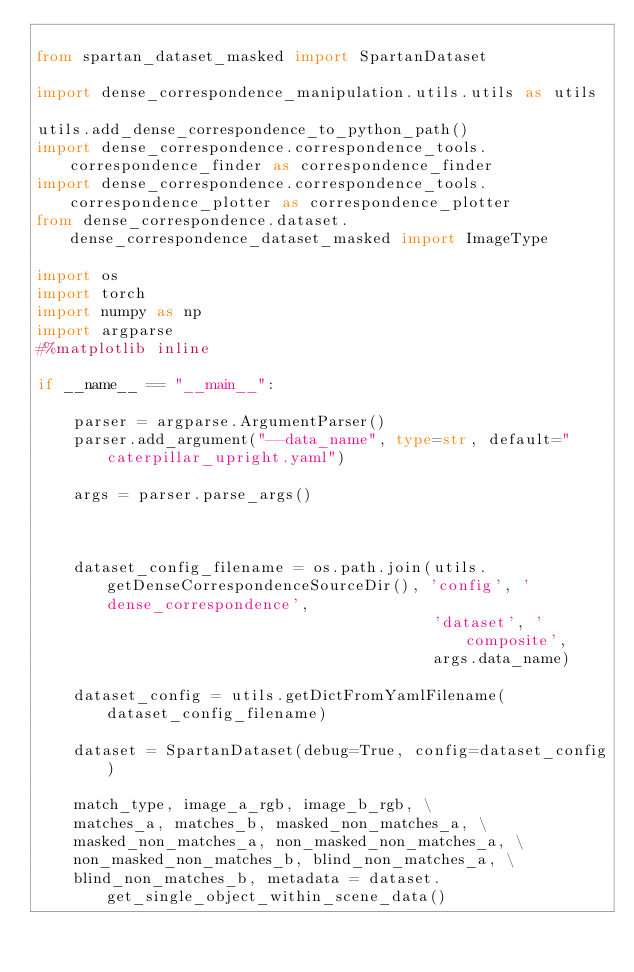<code> <loc_0><loc_0><loc_500><loc_500><_Python_>
from spartan_dataset_masked import SpartanDataset

import dense_correspondence_manipulation.utils.utils as utils

utils.add_dense_correspondence_to_python_path()
import dense_correspondence.correspondence_tools.correspondence_finder as correspondence_finder
import dense_correspondence.correspondence_tools.correspondence_plotter as correspondence_plotter
from dense_correspondence.dataset.dense_correspondence_dataset_masked import ImageType

import os
import torch
import numpy as np
import argparse
#%matplotlib inline

if __name__ == "__main__":

    parser = argparse.ArgumentParser()
    parser.add_argument("--data_name", type=str, default="caterpillar_upright.yaml")

    args = parser.parse_args()



    dataset_config_filename = os.path.join(utils.getDenseCorrespondenceSourceDir(), 'config', 'dense_correspondence',
                                           'dataset', 'composite',
                                           args.data_name)

    dataset_config = utils.getDictFromYamlFilename(dataset_config_filename)

    dataset = SpartanDataset(debug=True, config=dataset_config)

    match_type, image_a_rgb, image_b_rgb, \
    matches_a, matches_b, masked_non_matches_a, \
    masked_non_matches_a, non_masked_non_matches_a, \
    non_masked_non_matches_b, blind_non_matches_a, \
    blind_non_matches_b, metadata = dataset.get_single_object_within_scene_data()</code> 